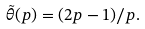<formula> <loc_0><loc_0><loc_500><loc_500>\tilde { \theta } ( p ) = ( 2 p - 1 ) / p .</formula> 